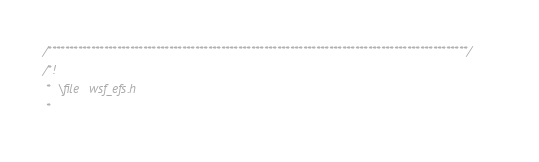Convert code to text. <code><loc_0><loc_0><loc_500><loc_500><_C_>/*************************************************************************************************/
/*!
 *  \file   wsf_efs.h
 *</code> 